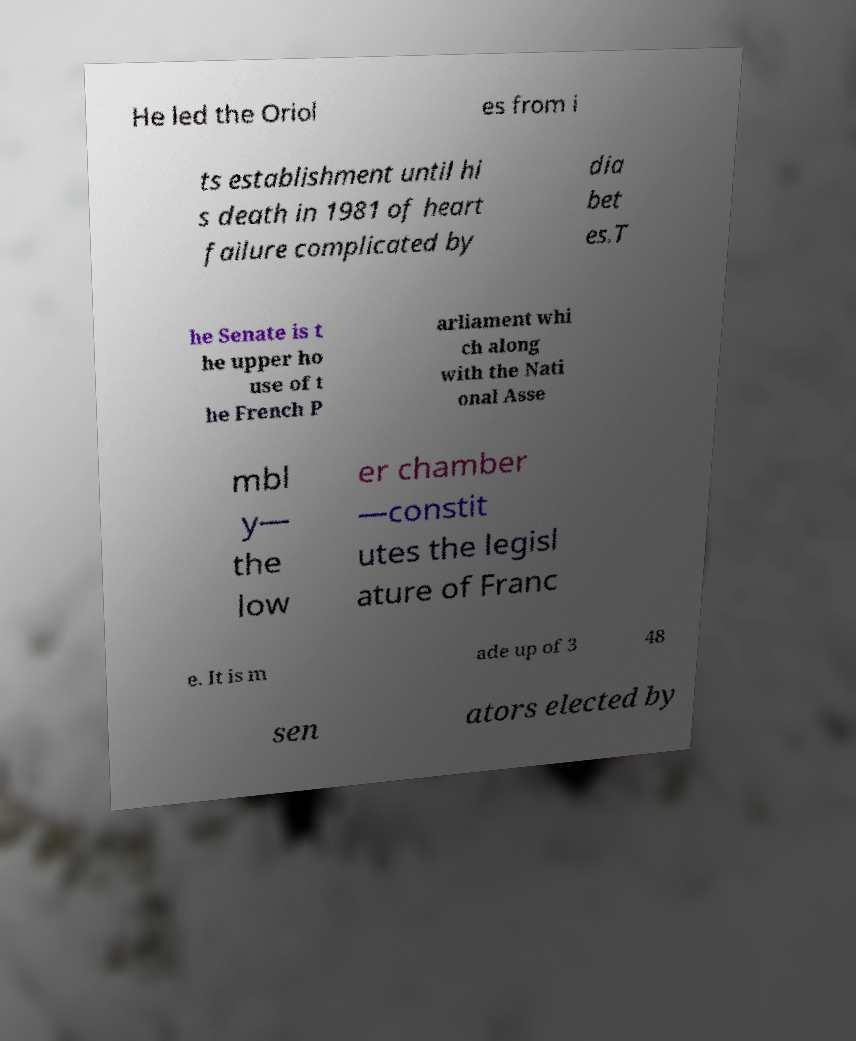Can you accurately transcribe the text from the provided image for me? He led the Oriol es from i ts establishment until hi s death in 1981 of heart failure complicated by dia bet es.T he Senate is t he upper ho use of t he French P arliament whi ch along with the Nati onal Asse mbl y— the low er chamber —constit utes the legisl ature of Franc e. It is m ade up of 3 48 sen ators elected by 